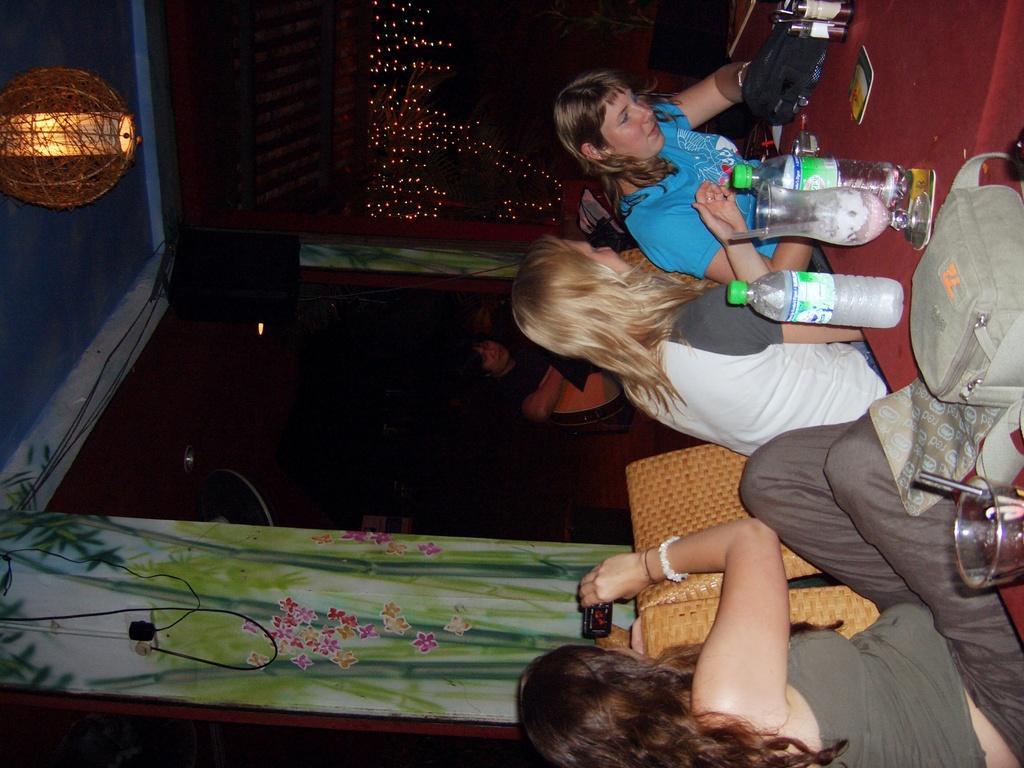In one or two sentences, can you explain what this image depicts? In this picture there are girls those who are sitting on the right side of the image and there are speakers and curtains on the left side of the image. 